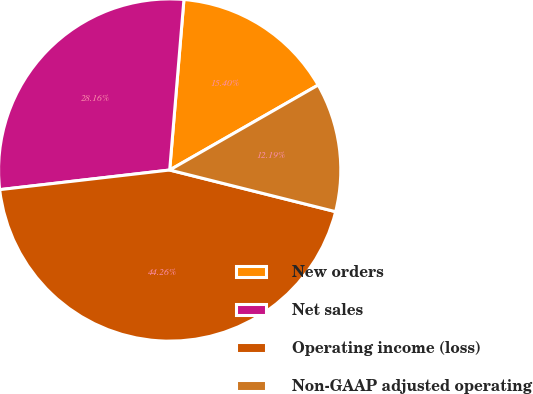<chart> <loc_0><loc_0><loc_500><loc_500><pie_chart><fcel>New orders<fcel>Net sales<fcel>Operating income (loss)<fcel>Non-GAAP adjusted operating<nl><fcel>15.4%<fcel>28.16%<fcel>44.26%<fcel>12.19%<nl></chart> 